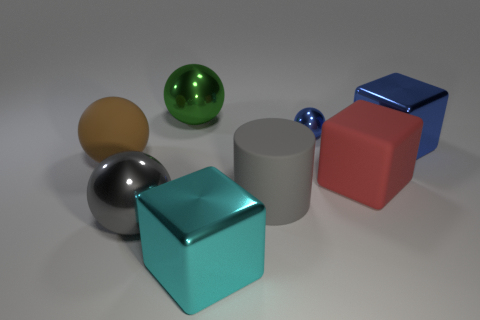Do the ball right of the large cyan thing and the big brown sphere have the same material?
Your answer should be very brief. No. Is there anything else that is the same shape as the big gray matte thing?
Offer a terse response. No. There is a cube that is the same color as the small object; what material is it?
Keep it short and to the point. Metal. What is the material of the block that is in front of the large gray object that is left of the big ball behind the big blue cube?
Ensure brevity in your answer.  Metal. Is there a big object that has the same color as the tiny metal thing?
Provide a short and direct response. Yes. The cyan metallic thing that is the same size as the gray ball is what shape?
Provide a short and direct response. Cube. There is a metallic sphere that is in front of the big brown thing; is its color the same as the big matte cylinder?
Provide a short and direct response. Yes. How many objects are either big gray things on the right side of the green ball or large cubes?
Offer a terse response. 4. Are there more gray balls behind the large brown matte ball than gray shiny spheres behind the gray matte object?
Provide a succinct answer. No. Are the gray ball and the large brown object made of the same material?
Make the answer very short. No. 